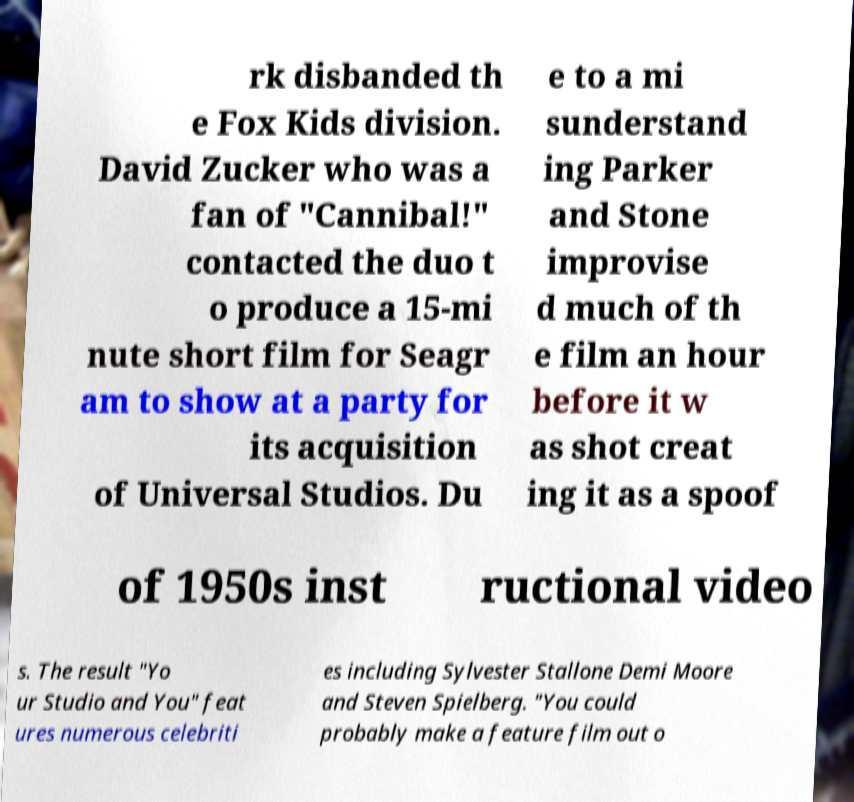Could you extract and type out the text from this image? rk disbanded th e Fox Kids division. David Zucker who was a fan of "Cannibal!" contacted the duo t o produce a 15-mi nute short film for Seagr am to show at a party for its acquisition of Universal Studios. Du e to a mi sunderstand ing Parker and Stone improvise d much of th e film an hour before it w as shot creat ing it as a spoof of 1950s inst ructional video s. The result "Yo ur Studio and You" feat ures numerous celebriti es including Sylvester Stallone Demi Moore and Steven Spielberg. "You could probably make a feature film out o 